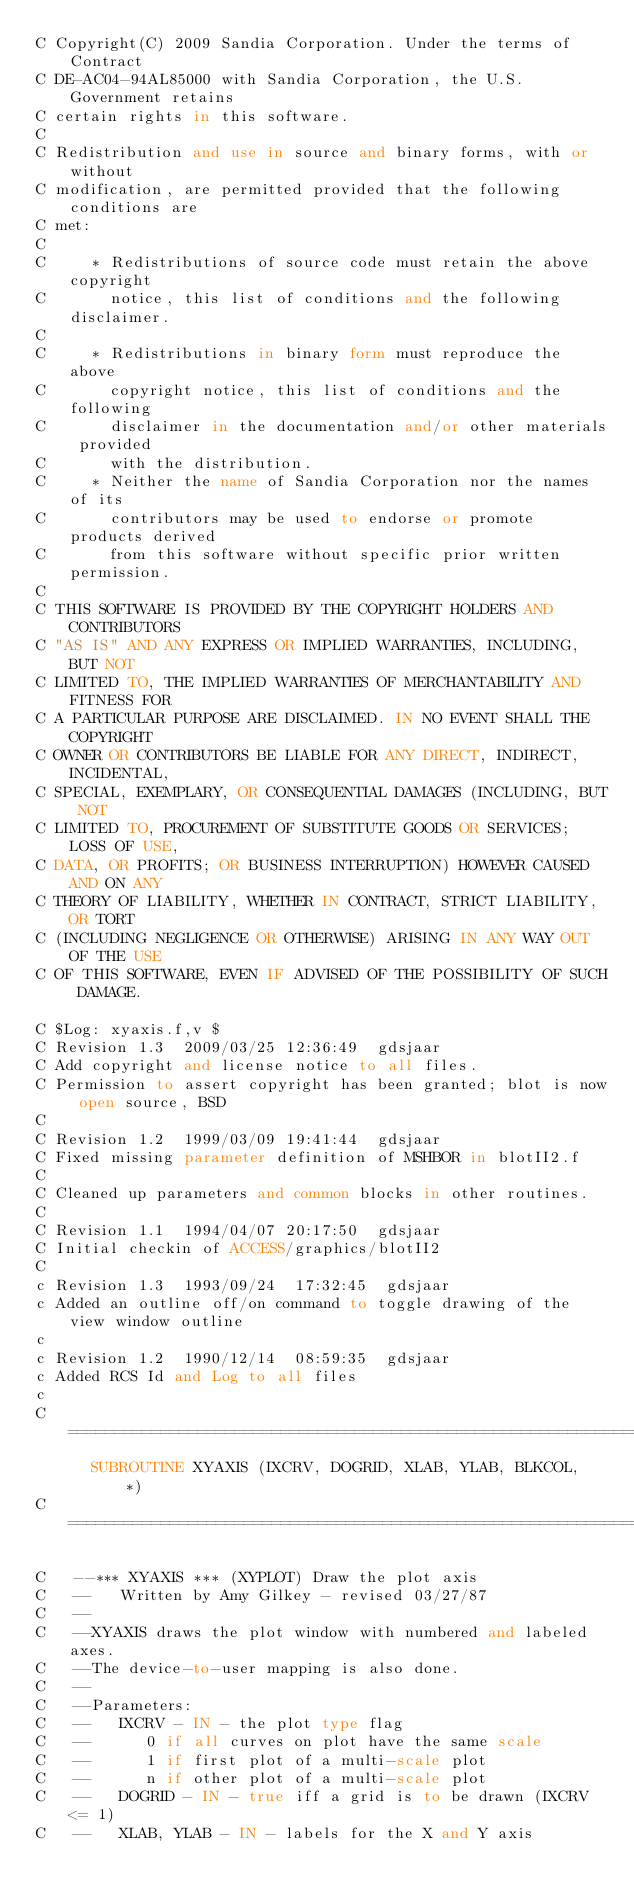<code> <loc_0><loc_0><loc_500><loc_500><_FORTRAN_>C Copyright(C) 2009 Sandia Corporation. Under the terms of Contract
C DE-AC04-94AL85000 with Sandia Corporation, the U.S. Government retains
C certain rights in this software.
C         
C Redistribution and use in source and binary forms, with or without
C modification, are permitted provided that the following conditions are
C met:
C 
C     * Redistributions of source code must retain the above copyright
C       notice, this list of conditions and the following disclaimer.
C 
C     * Redistributions in binary form must reproduce the above
C       copyright notice, this list of conditions and the following
C       disclaimer in the documentation and/or other materials provided
C       with the distribution.
C     * Neither the name of Sandia Corporation nor the names of its
C       contributors may be used to endorse or promote products derived
C       from this software without specific prior written permission.
C 
C THIS SOFTWARE IS PROVIDED BY THE COPYRIGHT HOLDERS AND CONTRIBUTORS
C "AS IS" AND ANY EXPRESS OR IMPLIED WARRANTIES, INCLUDING, BUT NOT
C LIMITED TO, THE IMPLIED WARRANTIES OF MERCHANTABILITY AND FITNESS FOR
C A PARTICULAR PURPOSE ARE DISCLAIMED. IN NO EVENT SHALL THE COPYRIGHT
C OWNER OR CONTRIBUTORS BE LIABLE FOR ANY DIRECT, INDIRECT, INCIDENTAL,
C SPECIAL, EXEMPLARY, OR CONSEQUENTIAL DAMAGES (INCLUDING, BUT NOT
C LIMITED TO, PROCUREMENT OF SUBSTITUTE GOODS OR SERVICES; LOSS OF USE,
C DATA, OR PROFITS; OR BUSINESS INTERRUPTION) HOWEVER CAUSED AND ON ANY
C THEORY OF LIABILITY, WHETHER IN CONTRACT, STRICT LIABILITY, OR TORT
C (INCLUDING NEGLIGENCE OR OTHERWISE) ARISING IN ANY WAY OUT OF THE USE
C OF THIS SOFTWARE, EVEN IF ADVISED OF THE POSSIBILITY OF SUCH DAMAGE.

C $Log: xyaxis.f,v $
C Revision 1.3  2009/03/25 12:36:49  gdsjaar
C Add copyright and license notice to all files.
C Permission to assert copyright has been granted; blot is now open source, BSD
C
C Revision 1.2  1999/03/09 19:41:44  gdsjaar
C Fixed missing parameter definition of MSHBOR in blotII2.f
C
C Cleaned up parameters and common blocks in other routines.
C
C Revision 1.1  1994/04/07 20:17:50  gdsjaar
C Initial checkin of ACCESS/graphics/blotII2
C
c Revision 1.3  1993/09/24  17:32:45  gdsjaar
c Added an outline off/on command to toggle drawing of the view window outline
c
c Revision 1.2  1990/12/14  08:59:35  gdsjaar
c Added RCS Id and Log to all files
c
C=======================================================================
      SUBROUTINE XYAXIS (IXCRV, DOGRID, XLAB, YLAB, BLKCOL,  *)
C=======================================================================

C   --*** XYAXIS *** (XYPLOT) Draw the plot axis
C   --   Written by Amy Gilkey - revised 03/27/87
C   --
C   --XYAXIS draws the plot window with numbered and labeled axes.
C   --The device-to-user mapping is also done.
C   --
C   --Parameters:
C   --   IXCRV - IN - the plot type flag
C   --      0 if all curves on plot have the same scale
C   --      1 if first plot of a multi-scale plot
C   --      n if other plot of a multi-scale plot
C   --   DOGRID - IN - true iff a grid is to be drawn (IXCRV <= 1)
C   --   XLAB, YLAB - IN - labels for the X and Y axis</code> 